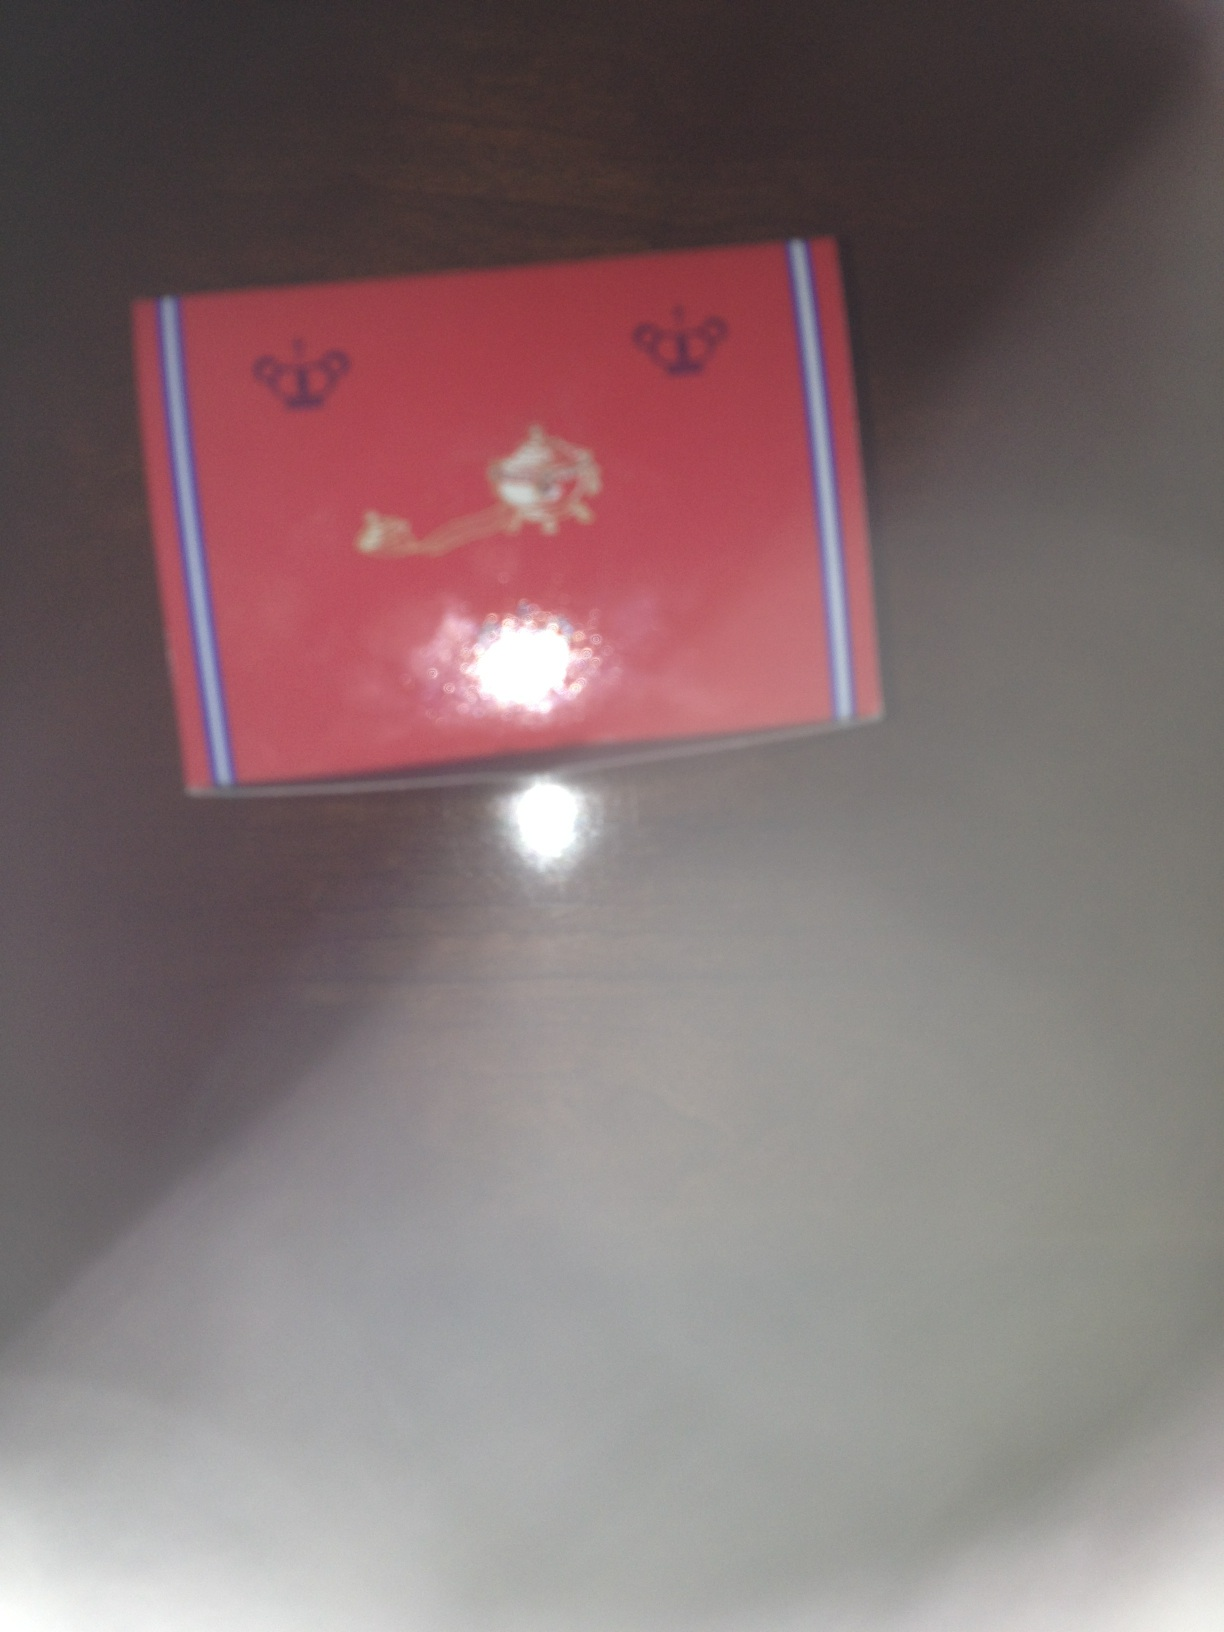What can you infer about the product based on its packaging design? The packaging of the product is red with decorative elements featuring crowns and what appears to be a lion or a decorative emblem. This suggests that the product might be of high value or associated with luxury or royalty. The design might be used for items such as gifts, special edition products, or high-end merchandise. Based on the color scheme and design, can you speculate what kind of product this could be? The color scheme and design of the packaging suggest it could be something luxurious and possibly related to fashion, cosmetics, or gourmet food. The prominent use of red, along with royal symbols, hints at a prestigious item, possibly a limited-edition product or a collectible. Imagine if this product had a historical connection. What story would you create behind it? Imagine this product was commissioned by a royal family centuries ago and has been a part of their legacy ever since. The red packaging with crown motifs symbolizes its connection to the monarchy. Legend has it that this item was gifted to foreign dignitaries as a sign of honor and diplomacy. Over time, it became a highly sought-after item, cherished for its historical value and luxurious quality. 